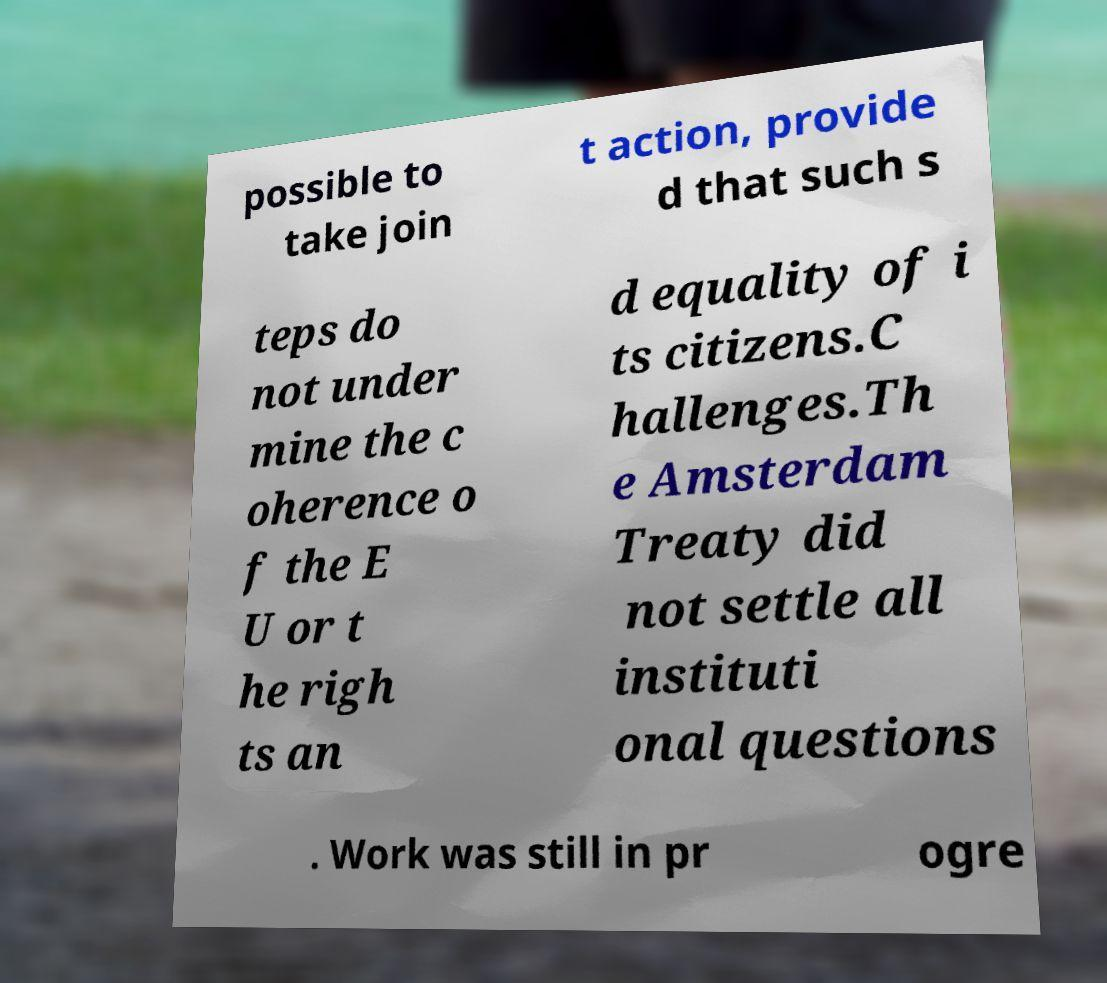Could you extract and type out the text from this image? possible to take join t action, provide d that such s teps do not under mine the c oherence o f the E U or t he righ ts an d equality of i ts citizens.C hallenges.Th e Amsterdam Treaty did not settle all instituti onal questions . Work was still in pr ogre 